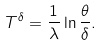Convert formula to latex. <formula><loc_0><loc_0><loc_500><loc_500>T ^ { \delta } = \frac { 1 } { \lambda } \ln \frac { \theta } { \delta } .</formula> 